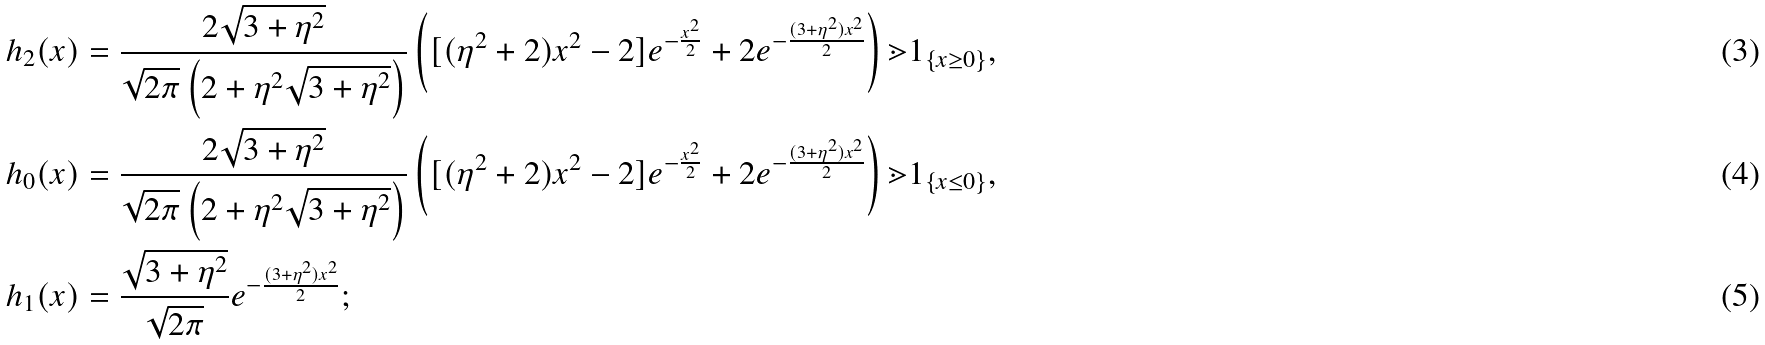<formula> <loc_0><loc_0><loc_500><loc_500>h _ { 2 } ( x ) & = \frac { 2 \sqrt { 3 + \eta ^ { 2 } } } { \sqrt { 2 \pi } \left ( 2 + \eta ^ { 2 } \sqrt { 3 + \eta ^ { 2 } } \right ) } \left ( [ ( \eta ^ { 2 } + 2 ) x ^ { 2 } - 2 ] e ^ { - \frac { x ^ { 2 } } { 2 } } + 2 e ^ { - \frac { ( 3 + \eta ^ { 2 } ) x ^ { 2 } } { 2 } } \right ) \mathbb { m } { 1 } _ { \{ x \geq 0 \} } , \\ h _ { 0 } ( x ) & = \frac { 2 \sqrt { 3 + \eta ^ { 2 } } } { \sqrt { 2 \pi } \left ( 2 + \eta ^ { 2 } \sqrt { 3 + \eta ^ { 2 } } \right ) } \left ( [ ( \eta ^ { 2 } + 2 ) x ^ { 2 } - 2 ] e ^ { - \frac { x ^ { 2 } } { 2 } } + 2 e ^ { - \frac { ( 3 + \eta ^ { 2 } ) x ^ { 2 } } { 2 } } \right ) \mathbb { m } { 1 } _ { \{ x \leq 0 \} } , \\ h _ { 1 } ( x ) & = \frac { \sqrt { 3 + \eta ^ { 2 } } } { \sqrt { 2 \pi } } e ^ { - \frac { ( 3 + \eta ^ { 2 } ) x ^ { 2 } } { 2 } } ;</formula> 